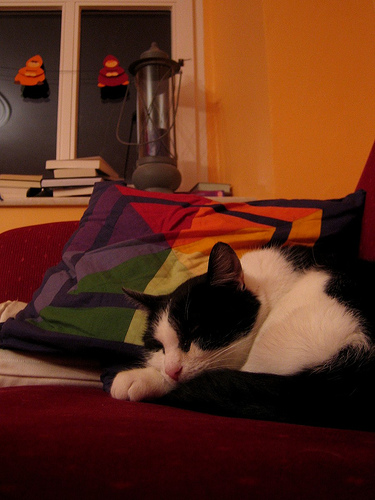<image>
Is there a cat behind the pillow? No. The cat is not behind the pillow. From this viewpoint, the cat appears to be positioned elsewhere in the scene. Is there a books on the sofa? No. The books is not positioned on the sofa. They may be near each other, but the books is not supported by or resting on top of the sofa. Is the cat to the right of the pillow? No. The cat is not to the right of the pillow. The horizontal positioning shows a different relationship. 